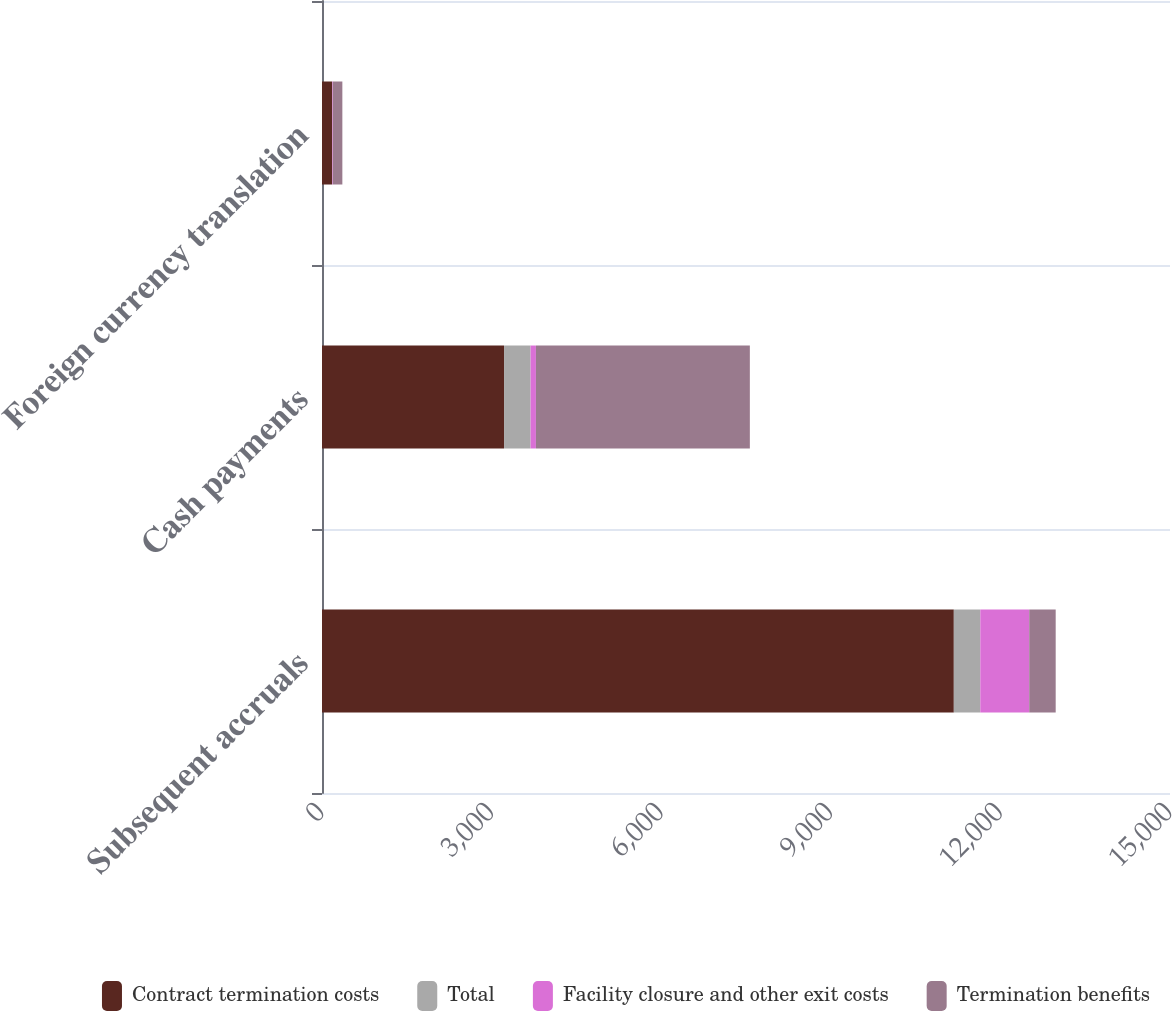<chart> <loc_0><loc_0><loc_500><loc_500><stacked_bar_chart><ecel><fcel>Subsequent accruals<fcel>Cash payments<fcel>Foreign currency translation<nl><fcel>Contract termination costs<fcel>11176<fcel>3220<fcel>179<nl><fcel>Total<fcel>468<fcel>469<fcel>1<nl><fcel>Facility closure and other exit costs<fcel>866<fcel>95<fcel>11<nl><fcel>Termination benefits<fcel>468<fcel>3784<fcel>169<nl></chart> 